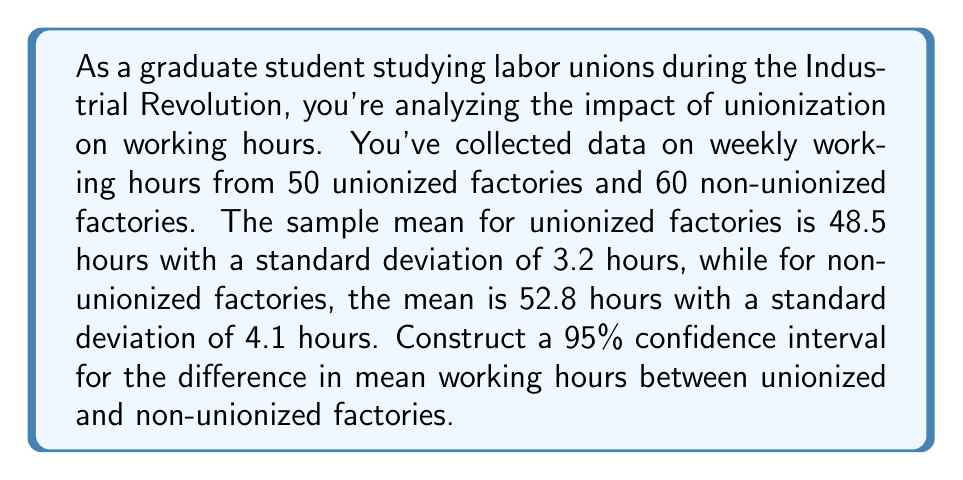Give your solution to this math problem. To construct a confidence interval for the difference in means, we'll follow these steps:

1) Define the parameters:
   $\bar{x}_1 = 48.5$ (unionized mean)
   $\bar{x}_2 = 52.8$ (non-unionized mean)
   $s_1 = 3.2$ (unionized standard deviation)
   $s_2 = 4.1$ (non-unionized standard deviation)
   $n_1 = 50$ (unionized sample size)
   $n_2 = 60$ (non-unionized sample size)

2) Calculate the difference in sample means:
   $\bar{x}_1 - \bar{x}_2 = 48.5 - 52.8 = -4.3$

3) Calculate the standard error of the difference:
   $SE = \sqrt{\frac{s_1^2}{n_1} + \frac{s_2^2}{n_2}} = \sqrt{\frac{3.2^2}{50} + \frac{4.1^2}{60}} = 0.7483$

4) For a 95% confidence interval, use $t$-distribution with degrees of freedom:
   $df = min(n_1 - 1, n_2 - 1) = min(49, 59) = 49$
   $t_{0.025, 49} \approx 2.01$ (from t-table)

5) Calculate the margin of error:
   $ME = t_{0.025, 49} \times SE = 2.01 \times 0.7483 = 1.5041$

6) Construct the confidence interval:
   $(\bar{x}_1 - \bar{x}_2 - ME, \bar{x}_1 - \bar{x}_2 + ME)$
   $(-4.3 - 1.5041, -4.3 + 1.5041)$
   $(-5.8041, -2.7959)$
Answer: (-5.8041, -2.7959) hours 